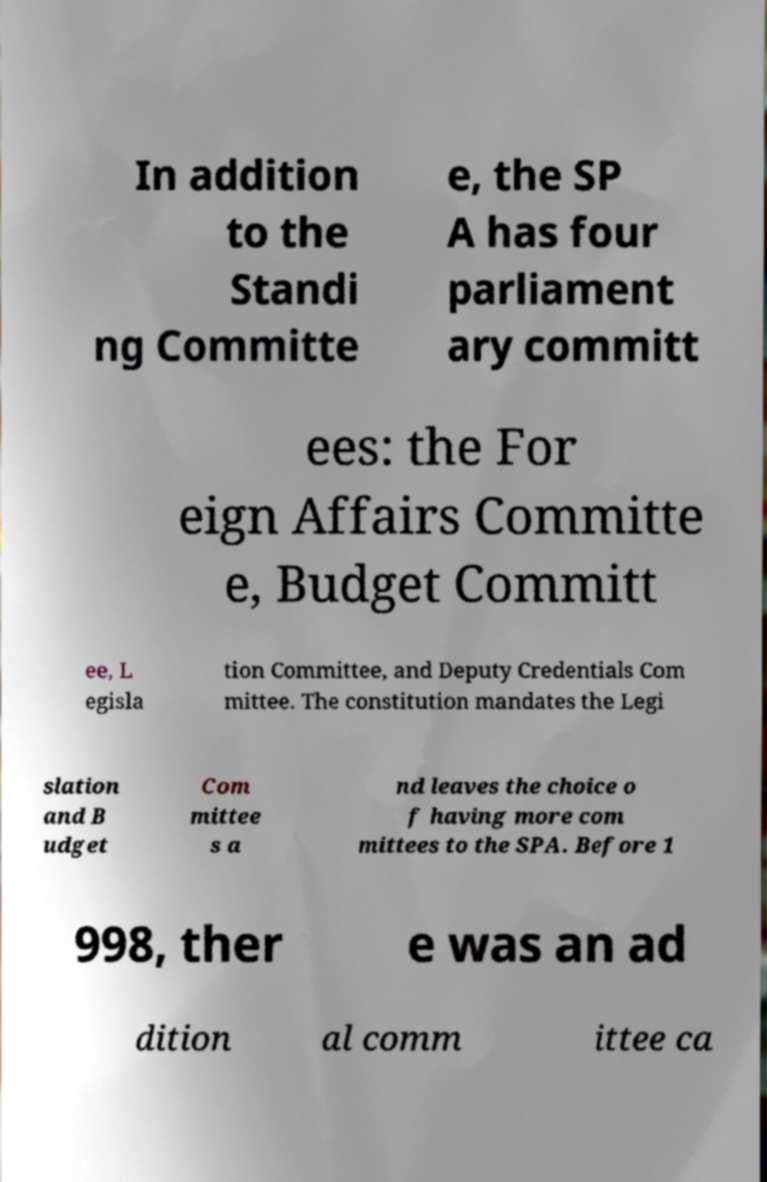Please identify and transcribe the text found in this image. In addition to the Standi ng Committe e, the SP A has four parliament ary committ ees: the For eign Affairs Committe e, Budget Committ ee, L egisla tion Committee, and Deputy Credentials Com mittee. The constitution mandates the Legi slation and B udget Com mittee s a nd leaves the choice o f having more com mittees to the SPA. Before 1 998, ther e was an ad dition al comm ittee ca 